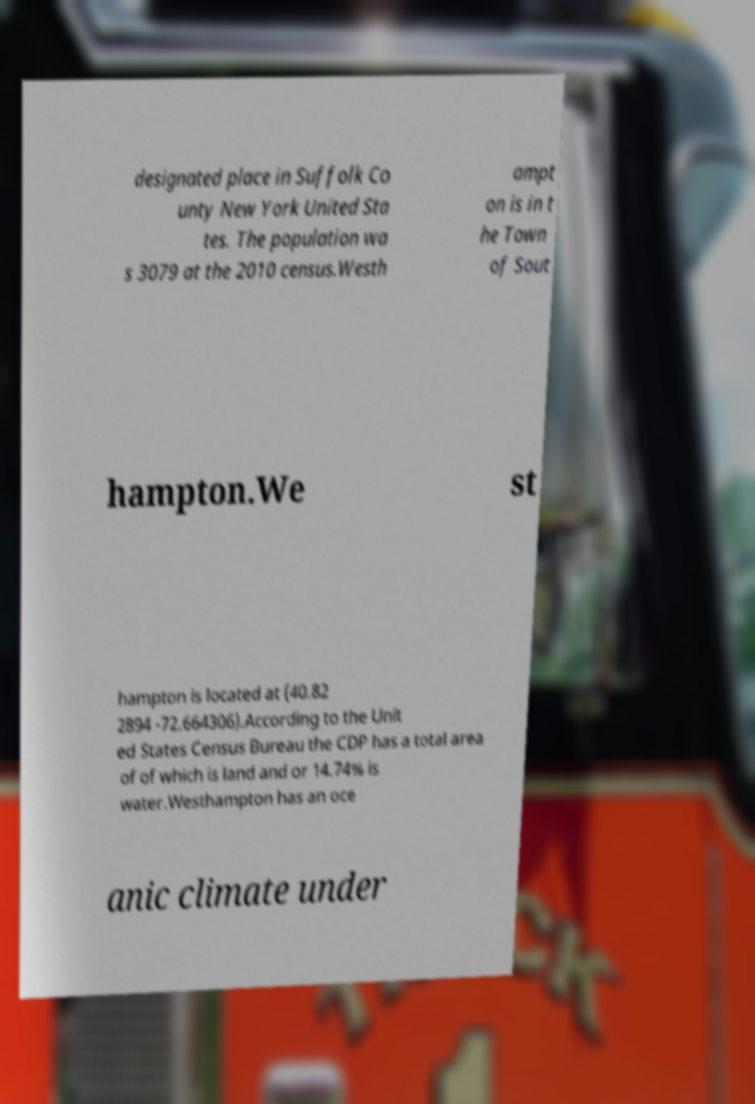Please read and relay the text visible in this image. What does it say? designated place in Suffolk Co unty New York United Sta tes. The population wa s 3079 at the 2010 census.Westh ampt on is in t he Town of Sout hampton.We st hampton is located at (40.82 2894 -72.664306).According to the Unit ed States Census Bureau the CDP has a total area of of which is land and or 14.74% is water.Westhampton has an oce anic climate under 